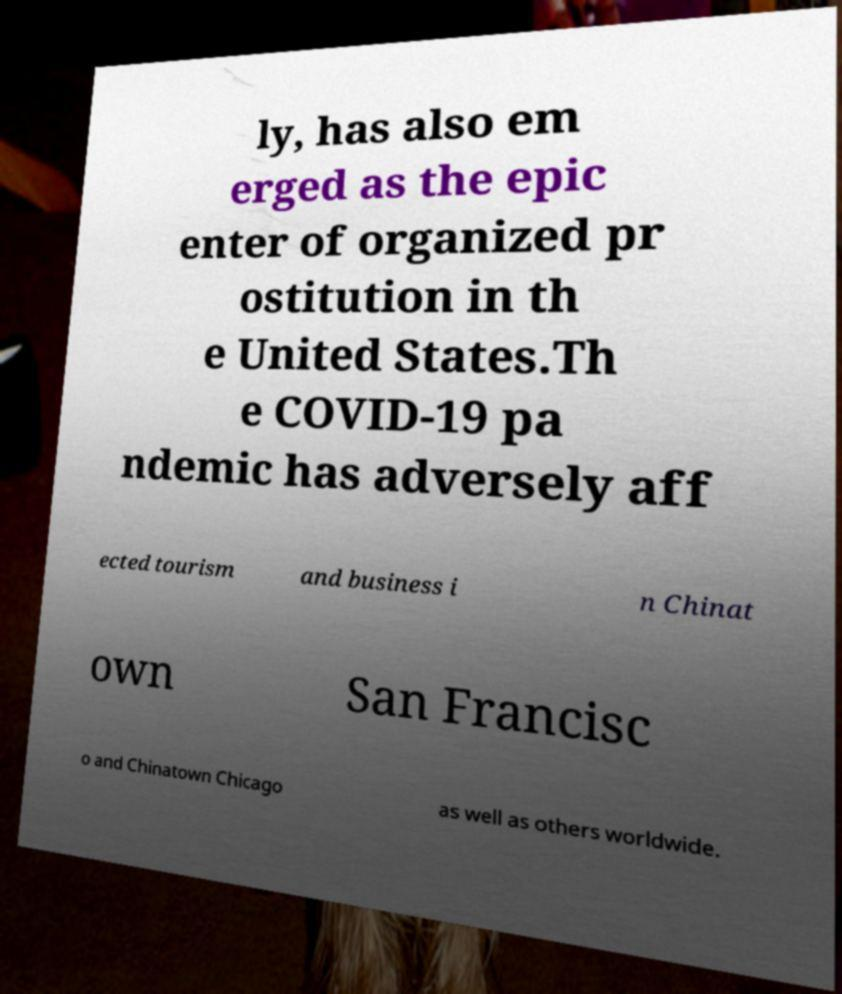Please identify and transcribe the text found in this image. ly, has also em erged as the epic enter of organized pr ostitution in th e United States.Th e COVID-19 pa ndemic has adversely aff ected tourism and business i n Chinat own San Francisc o and Chinatown Chicago as well as others worldwide. 